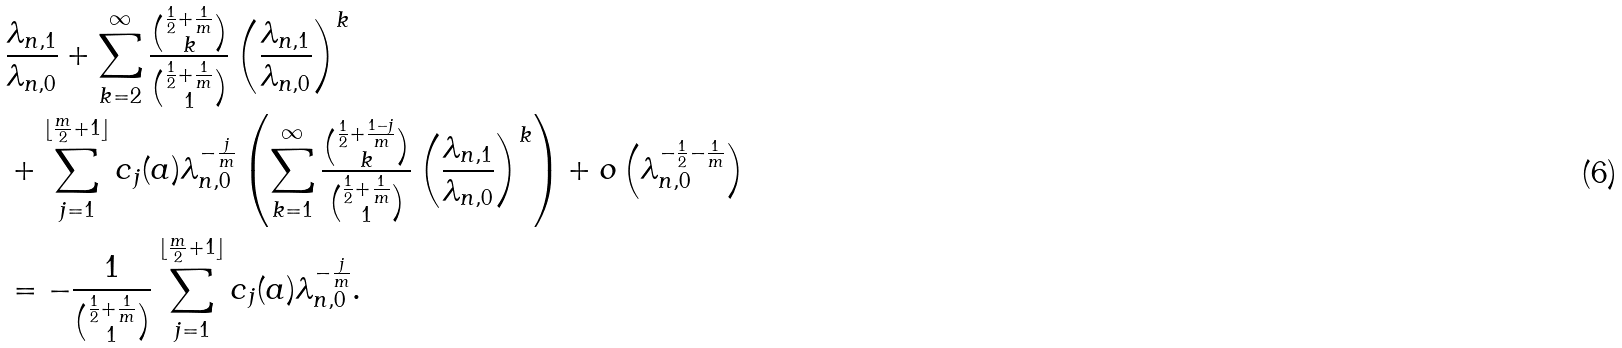Convert formula to latex. <formula><loc_0><loc_0><loc_500><loc_500>& \frac { \lambda _ { n , 1 } } { \lambda _ { n , 0 } } + \sum _ { k = 2 } ^ { \infty } \frac { { \frac { 1 } { 2 } + \frac { 1 } { m } \choose k } } { { \frac { 1 } { 2 } + \frac { 1 } { m } \choose 1 } } \left ( \frac { \lambda _ { n , 1 } } { \lambda _ { n , 0 } } \right ) ^ { k } \\ & + \sum _ { j = 1 } ^ { \lfloor \frac { m } { 2 } + 1 \rfloor } c _ { j } ( a ) \lambda _ { n , 0 } ^ { - \frac { j } { m } } \left ( \sum _ { k = 1 } ^ { \infty } \frac { { \frac { 1 } { 2 } + \frac { 1 - j } { m } \choose k } } { { \frac { 1 } { 2 } + \frac { 1 } { m } \choose 1 } } \left ( \frac { \lambda _ { n , 1 } } { \lambda _ { n , 0 } } \right ) ^ { k } \right ) + o \left ( \lambda _ { n , 0 } ^ { - \frac { 1 } { 2 } - \frac { 1 } { m } } \right ) \\ & = - \frac { 1 } { { \frac { 1 } { 2 } + \frac { 1 } { m } \choose 1 } } \sum _ { j = 1 } ^ { \lfloor \frac { m } { 2 } + 1 \rfloor } c _ { j } ( a ) \lambda _ { n , 0 } ^ { - \frac { j } { m } } .</formula> 